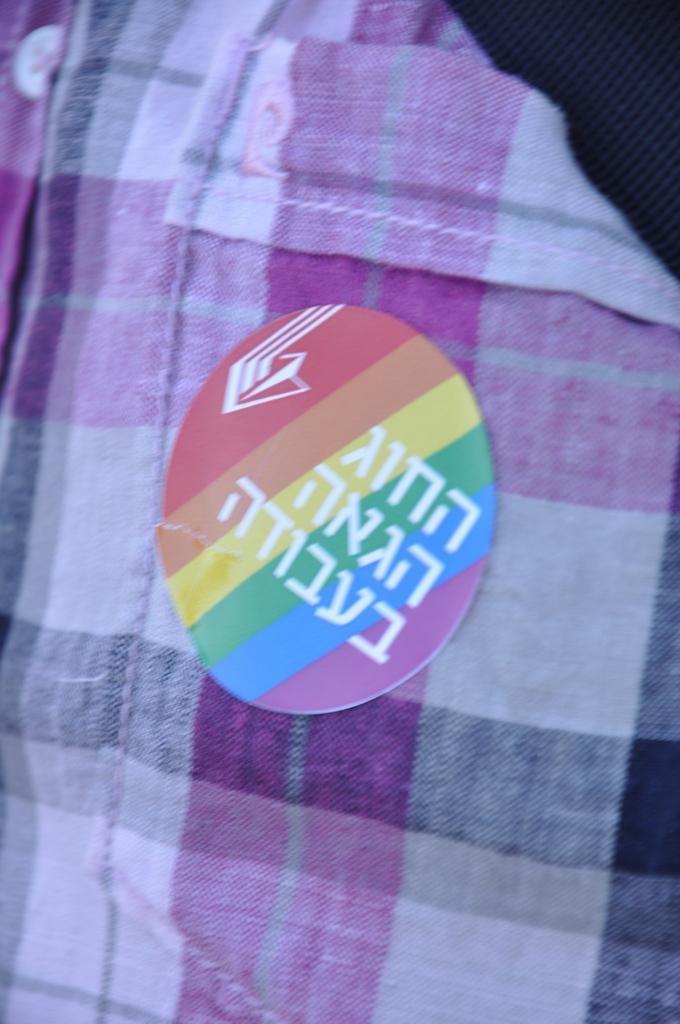Please provide a concise description of this image. In this picture we can see a cloth and it seems like a sticker on a cloth. 